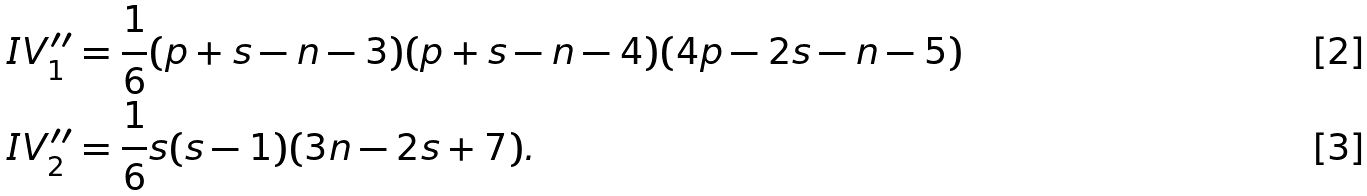<formula> <loc_0><loc_0><loc_500><loc_500>I V ^ { \prime \prime } _ { 1 } & = \frac { 1 } { 6 } ( p + s - n - 3 ) ( p + s - n - 4 ) ( 4 p - 2 s - n - 5 ) \\ I V ^ { \prime \prime } _ { 2 } & = \frac { 1 } { 6 } s ( s - 1 ) ( 3 n - 2 s + 7 ) .</formula> 